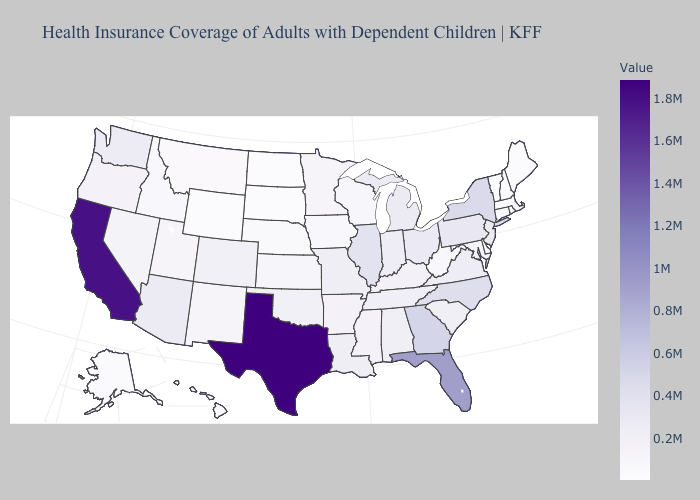Which states hav the highest value in the MidWest?
Be succinct. Illinois. Which states hav the highest value in the MidWest?
Quick response, please. Illinois. Which states have the lowest value in the USA?
Short answer required. Vermont. Which states hav the highest value in the Northeast?
Give a very brief answer. New York. 